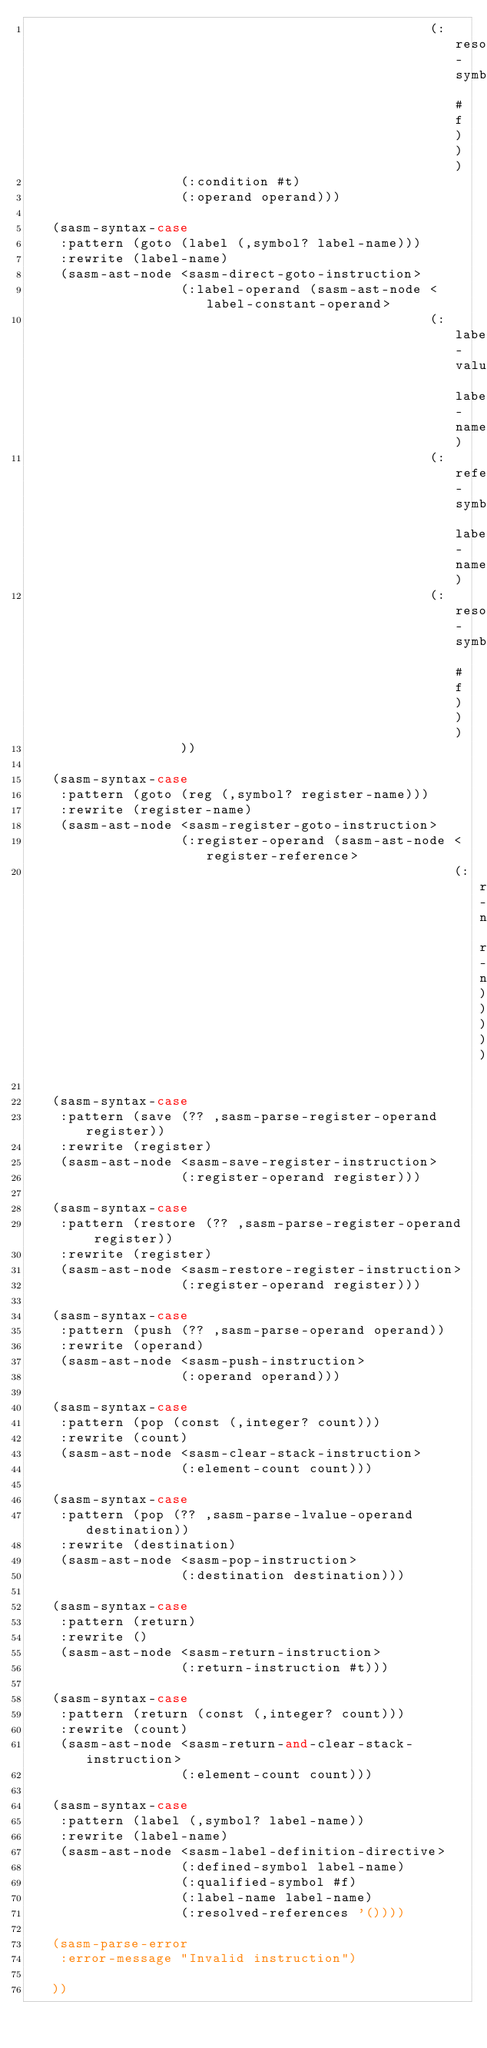<code> <loc_0><loc_0><loc_500><loc_500><_Scheme_>                                                  (:resolved-symbol #f)))
                   (:condition #t)
                   (:operand operand)))

   (sasm-syntax-case
    :pattern (goto (label (,symbol? label-name)))
    :rewrite (label-name)
    (sasm-ast-node <sasm-direct-goto-instruction>
                   (:label-operand (sasm-ast-node <label-constant-operand>
                                                  (:label-value label-name)
                                                  (:referenced-symbol label-name)
                                                  (:resolved-symbol #f)))
                   ))

   (sasm-syntax-case
    :pattern (goto (reg (,symbol? register-name)))
    :rewrite (register-name)
    (sasm-ast-node <sasm-register-goto-instruction>
                   (:register-operand (sasm-ast-node <register-reference>
                                                     (:register-name register-name)))))

   (sasm-syntax-case
    :pattern (save (?? ,sasm-parse-register-operand register))
    :rewrite (register)
    (sasm-ast-node <sasm-save-register-instruction>
                   (:register-operand register)))

   (sasm-syntax-case
    :pattern (restore (?? ,sasm-parse-register-operand register))
    :rewrite (register)
    (sasm-ast-node <sasm-restore-register-instruction>
                   (:register-operand register)))

   (sasm-syntax-case
    :pattern (push (?? ,sasm-parse-operand operand))
    :rewrite (operand)
    (sasm-ast-node <sasm-push-instruction>
                   (:operand operand)))

   (sasm-syntax-case
    :pattern (pop (const (,integer? count)))
    :rewrite (count)
    (sasm-ast-node <sasm-clear-stack-instruction>
                   (:element-count count)))

   (sasm-syntax-case
    :pattern (pop (?? ,sasm-parse-lvalue-operand destination))
    :rewrite (destination)
    (sasm-ast-node <sasm-pop-instruction>
                   (:destination destination)))

   (sasm-syntax-case
    :pattern (return)
    :rewrite ()
    (sasm-ast-node <sasm-return-instruction>
                   (:return-instruction #t)))

   (sasm-syntax-case
    :pattern (return (const (,integer? count)))
    :rewrite (count)
    (sasm-ast-node <sasm-return-and-clear-stack-instruction>
                   (:element-count count)))

   (sasm-syntax-case
    :pattern (label (,symbol? label-name))
    :rewrite (label-name)
    (sasm-ast-node <sasm-label-definition-directive>
                   (:defined-symbol label-name)
                   (:qualified-symbol #f)
                   (:label-name label-name)
                   (:resolved-references '())))

   (sasm-parse-error
    :error-message "Invalid instruction")

   ))

</code> 